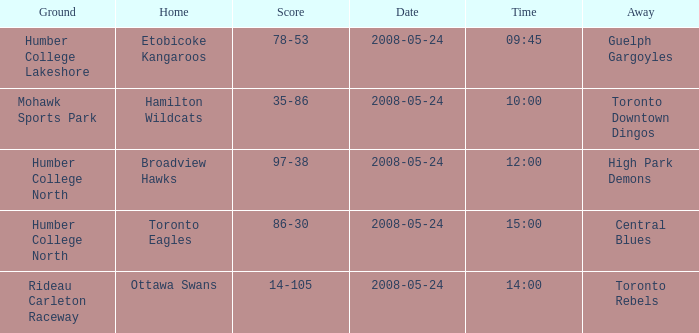Who was the away team of the game at the time 15:00? Central Blues. 